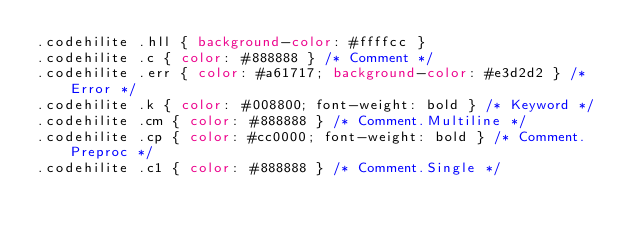Convert code to text. <code><loc_0><loc_0><loc_500><loc_500><_CSS_>.codehilite .hll { background-color: #ffffcc }
.codehilite .c { color: #888888 } /* Comment */
.codehilite .err { color: #a61717; background-color: #e3d2d2 } /* Error */
.codehilite .k { color: #008800; font-weight: bold } /* Keyword */
.codehilite .cm { color: #888888 } /* Comment.Multiline */
.codehilite .cp { color: #cc0000; font-weight: bold } /* Comment.Preproc */
.codehilite .c1 { color: #888888 } /* Comment.Single */</code> 